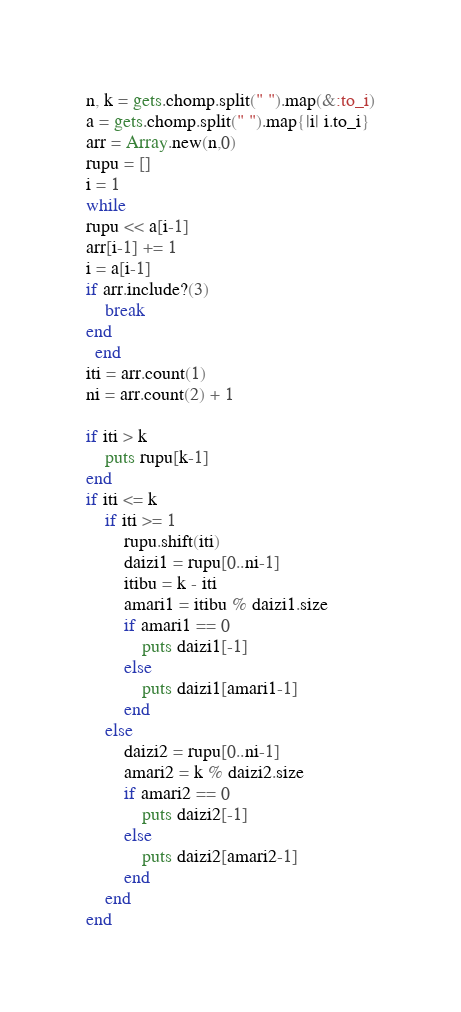<code> <loc_0><loc_0><loc_500><loc_500><_Ruby_>n, k = gets.chomp.split(" ").map(&:to_i)
a = gets.chomp.split(" ").map{|i| i.to_i}
arr = Array.new(n,0)
rupu = []
i = 1
while
rupu << a[i-1]
arr[i-1] += 1
i = a[i-1]
if arr.include?(3)
    break
end
  end
iti = arr.count(1)
ni = arr.count(2) + 1

if iti > k
    puts rupu[k-1]
end
if iti <= k
    if iti >= 1
        rupu.shift(iti)
        daizi1 = rupu[0..ni-1]
        itibu = k - iti
        amari1 = itibu % daizi1.size
        if amari1 == 0
            puts daizi1[-1]
        else
            puts daizi1[amari1-1]
        end
    else
        daizi2 = rupu[0..ni-1] 
        amari2 = k % daizi2.size
        if amari2 == 0
            puts daizi2[-1]
        else
            puts daizi2[amari2-1]
        end
    end
end</code> 